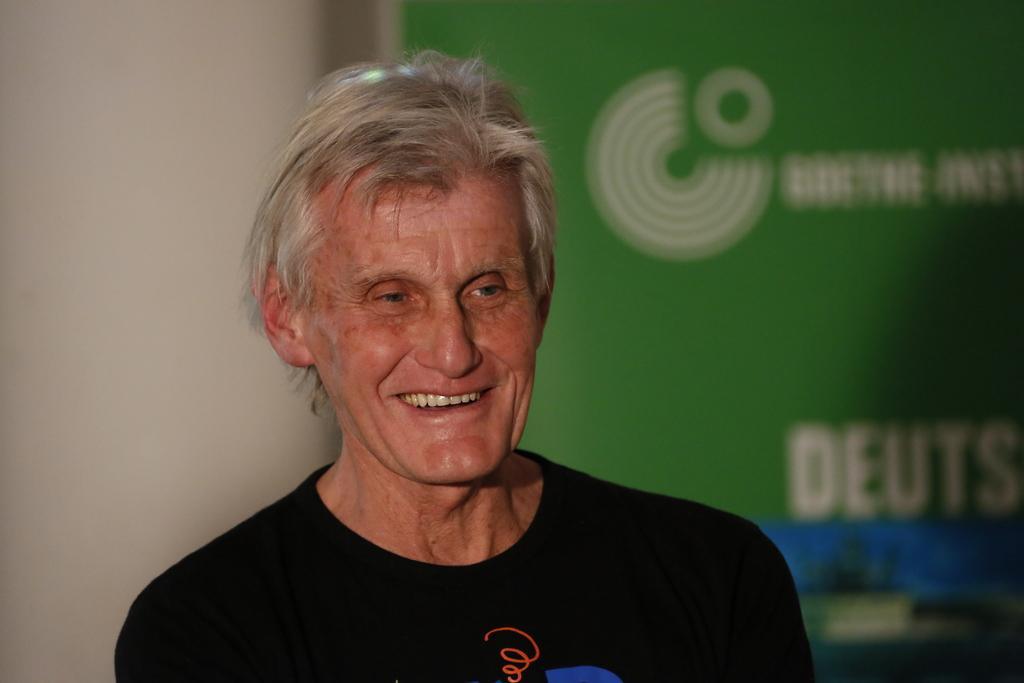Can you describe this image briefly? In the center of this picture we can see a person wearing black color dress and smiling. In the background we can see the wall and the text on the banner. 